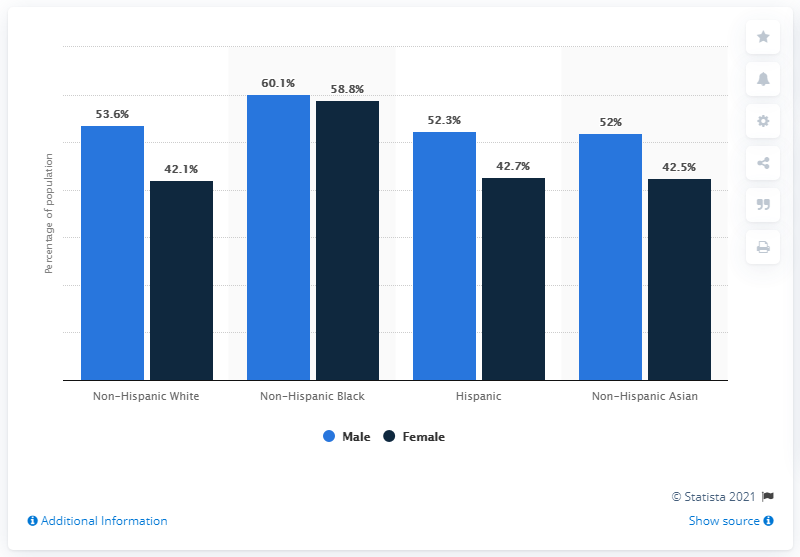Identify some key points in this picture. Cardiovascular diseases are more prevalent in males than in females. A study found that 52.3% of Hispanic males had some form of cardiovascular disease. According to the provided data, 42.7% of Hispanic females had some form of cardiovascular disease. The difference between male and female of Hispanic race is 9.6%. 